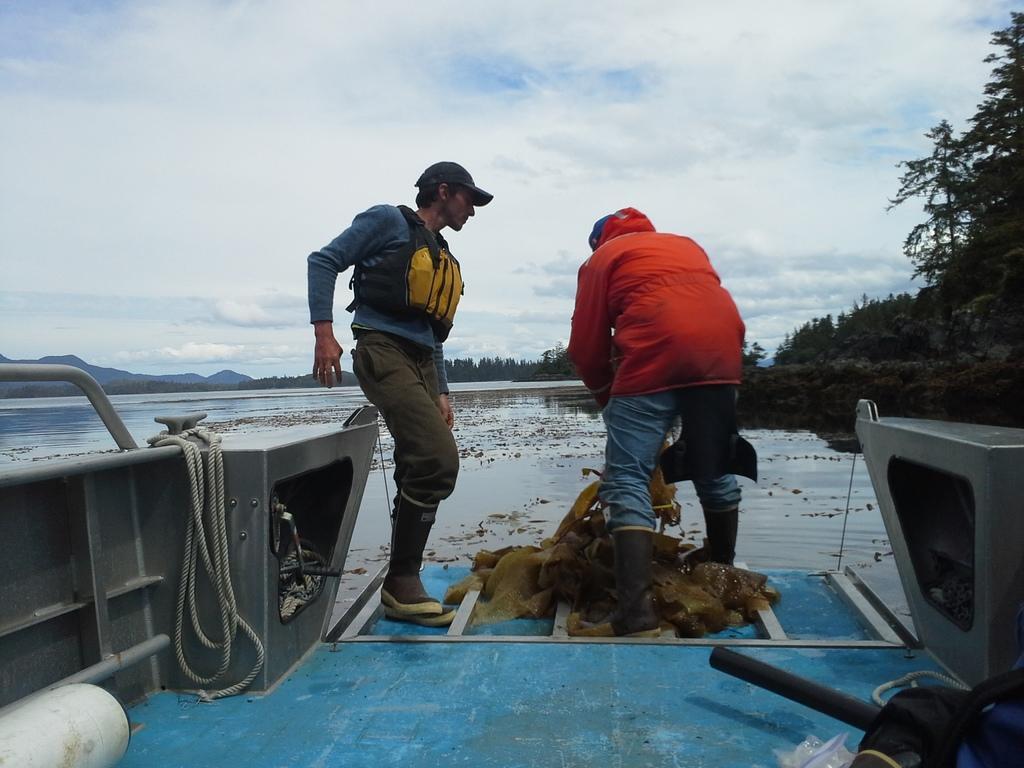Can you describe this image briefly? This picture shows couple of men standing on the boat and they wore caps on their heads and jackets and we see trees and a blue cloudy sky and we see hills and a rope. 